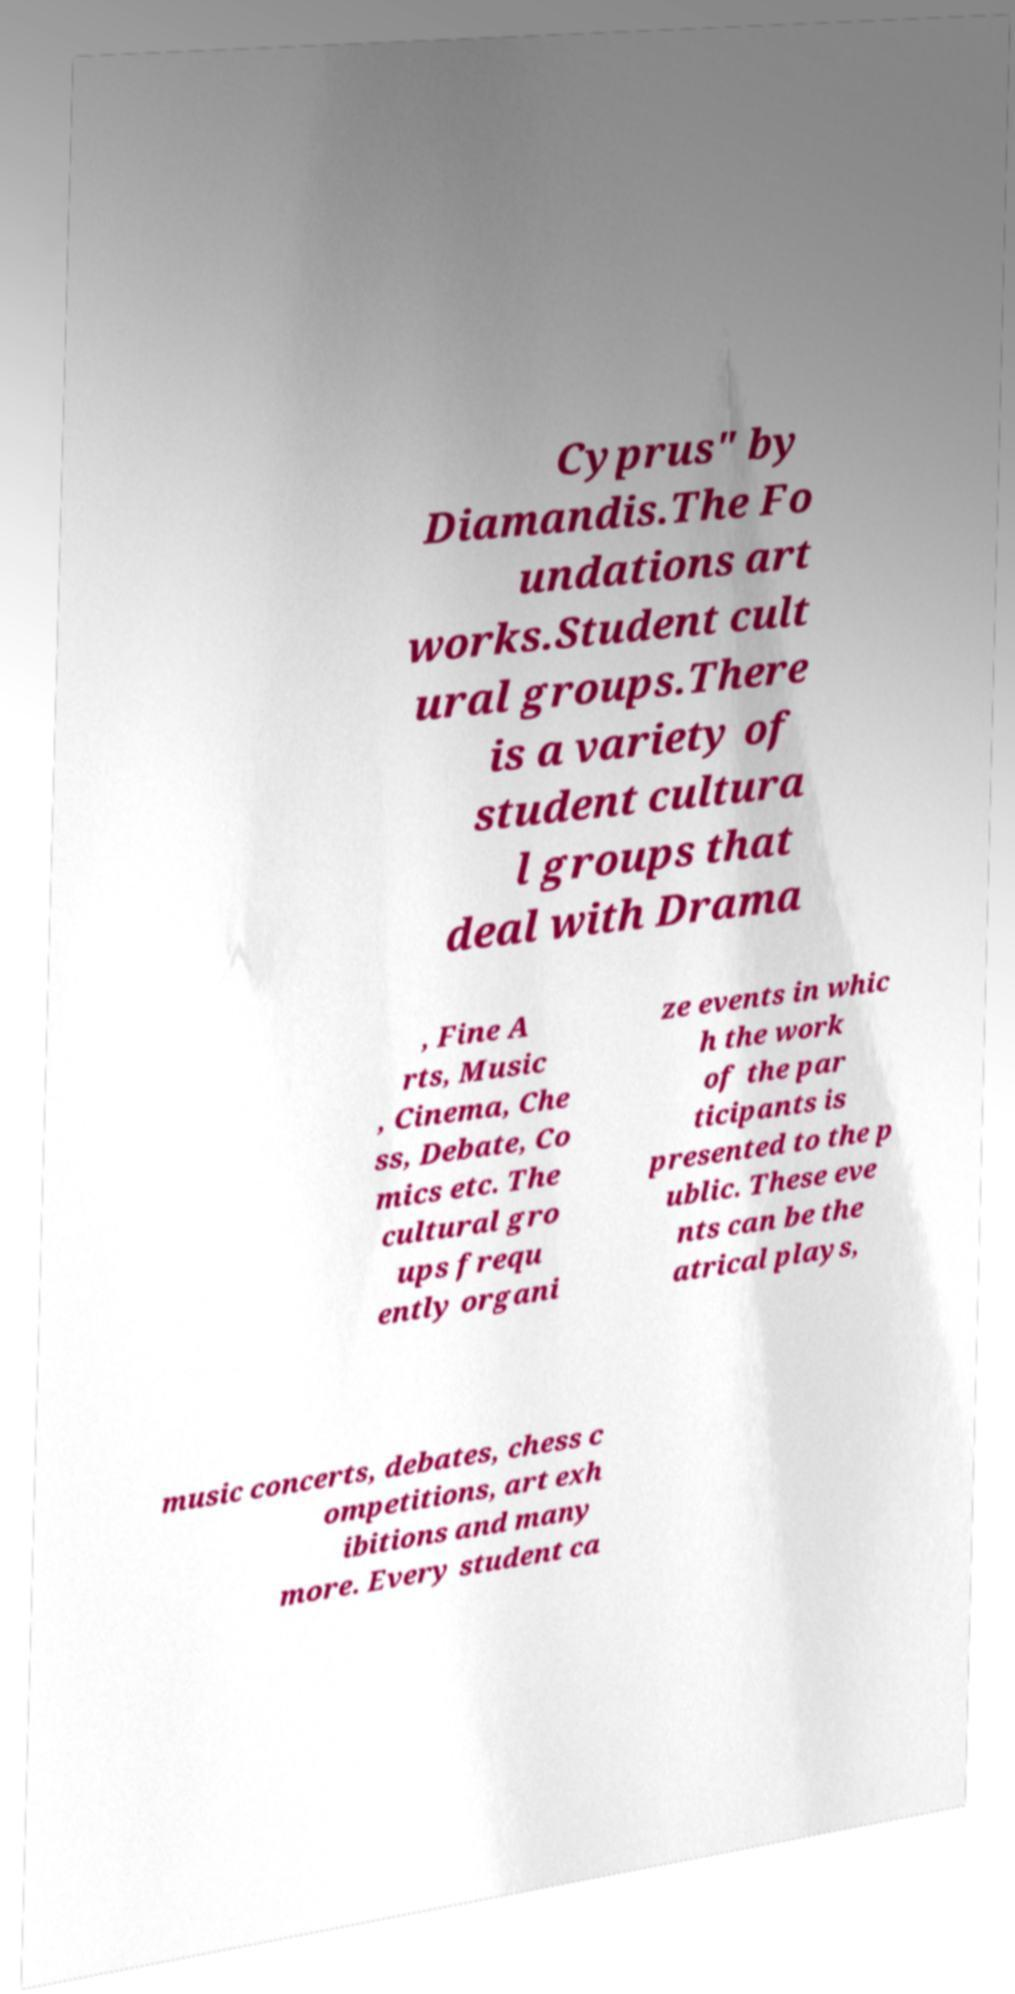Can you accurately transcribe the text from the provided image for me? Cyprus" by Diamandis.The Fo undations art works.Student cult ural groups.There is a variety of student cultura l groups that deal with Drama , Fine A rts, Music , Cinema, Che ss, Debate, Co mics etc. The cultural gro ups frequ ently organi ze events in whic h the work of the par ticipants is presented to the p ublic. These eve nts can be the atrical plays, music concerts, debates, chess c ompetitions, art exh ibitions and many more. Every student ca 